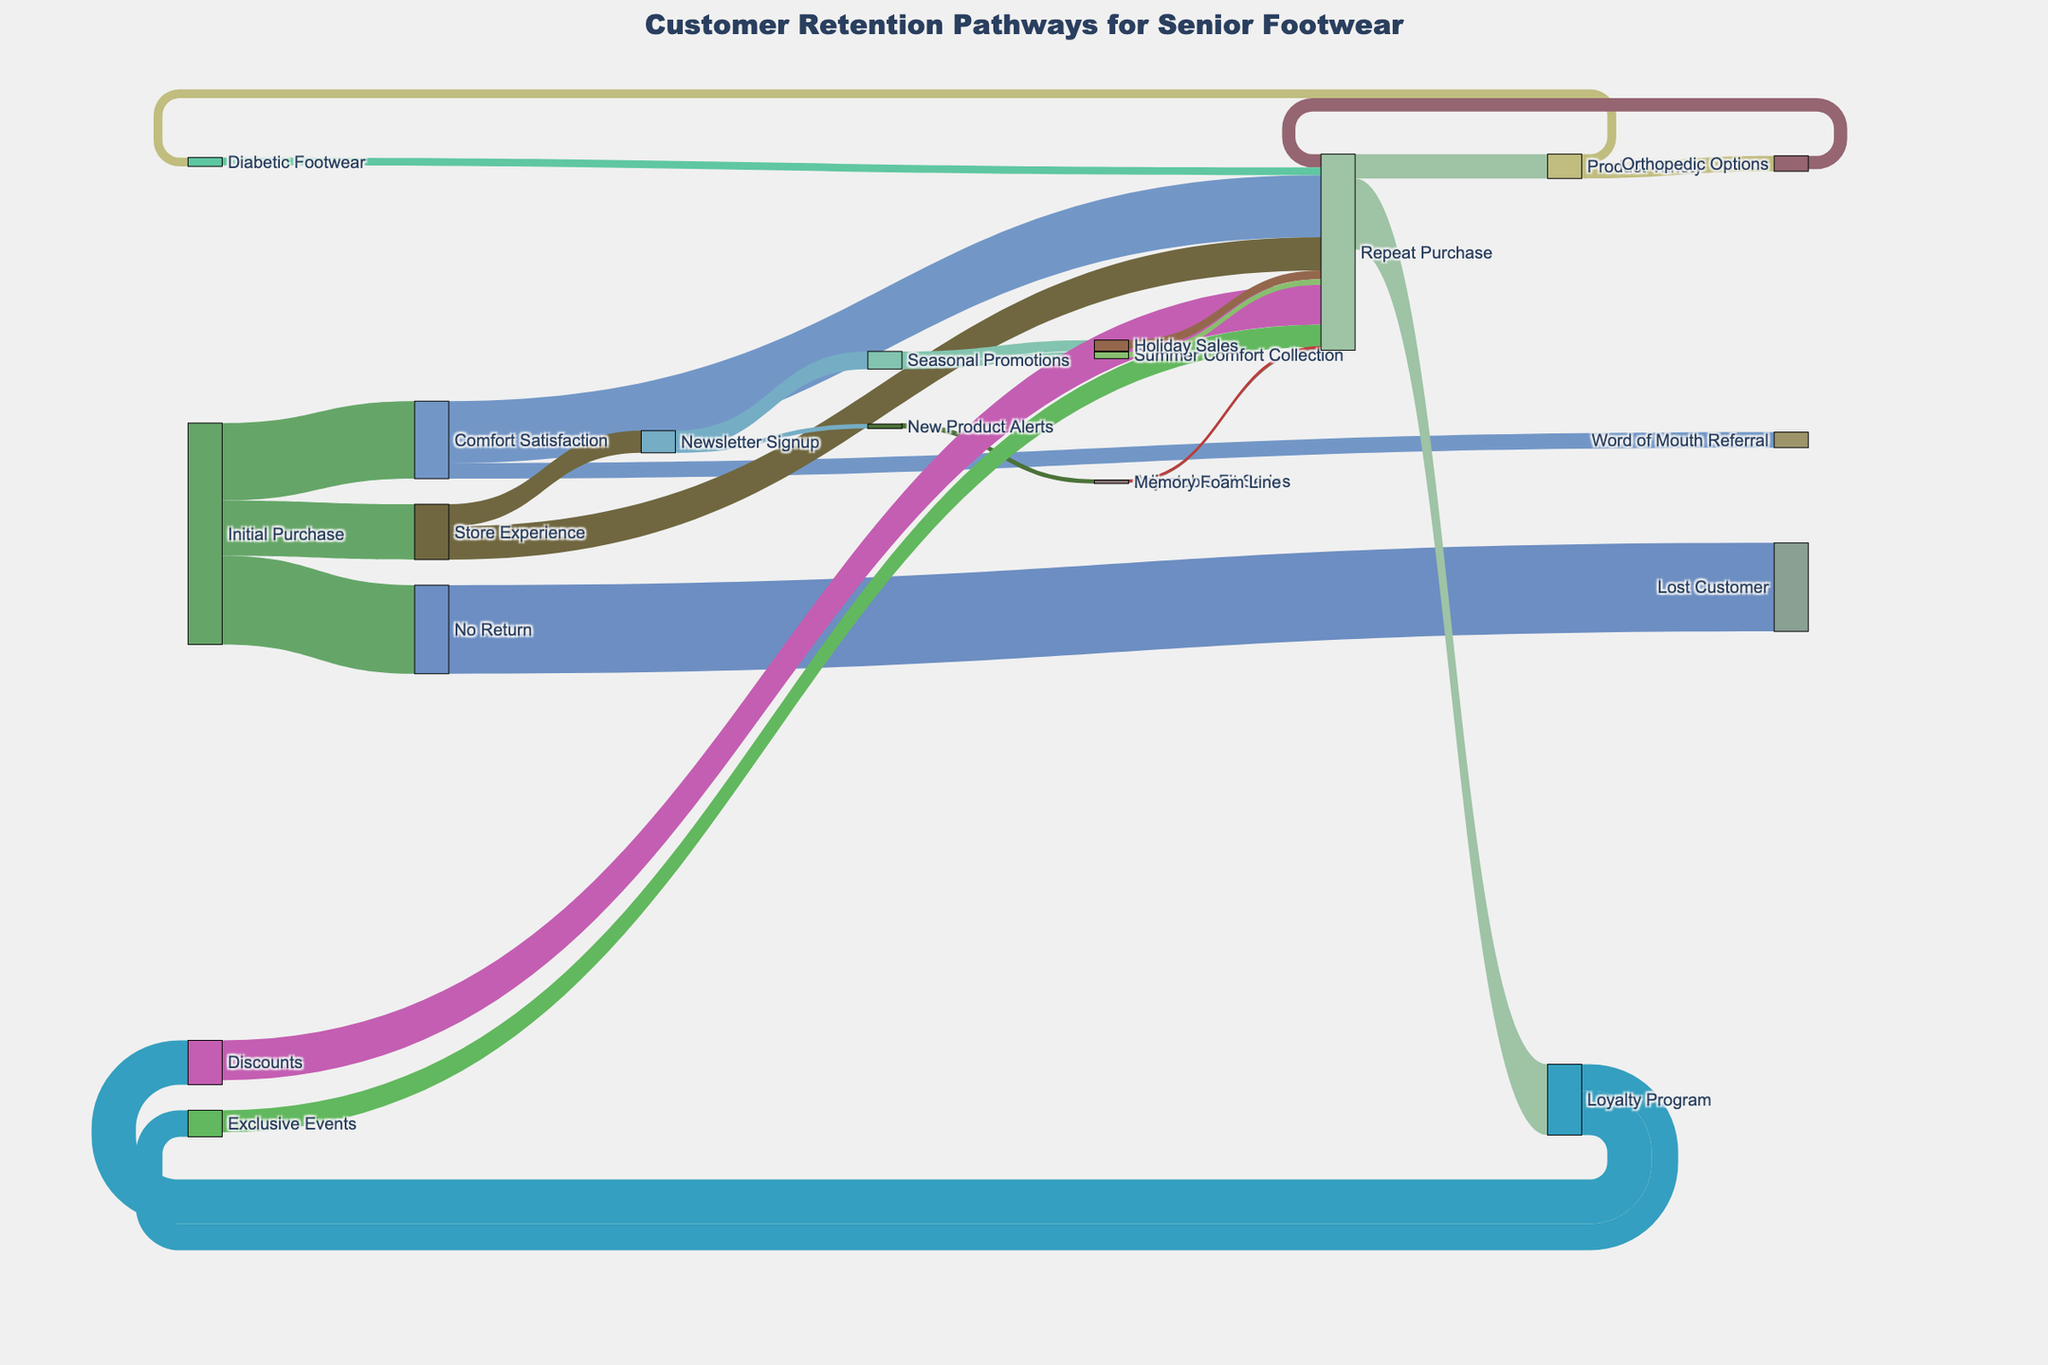What's the title of the figure? The title is displayed at the very top of the figure, centered for better readability.
Answer: "Customer Retention Pathways for Senior Footwear" How many customers did not return after their initial purchase? Identify the flow labeled "No Return" coming out of "Initial Purchase" and check the value associated with it.
Answer: 400 Between “Comfort Satisfaction” and “Store Experience,” which pathway leads to more repeat purchases? Compare the values of the flows labeled "Repeat Purchase" from both “Comfort Satisfaction” and “Store Experience.”
Answer: "Comfort Satisfaction" Which factor under "Loyalty Program" leads to more repeat purchases? Look at the values of the flows stemming from "Loyalty Program" and check which one has the higher value.
Answer: Discounts What is the total number of customers who signed up for the newsletter? Sum up the values of flows labeled "Newsletter Signup" stemming from "Store Experience."
Answer: 100 What's the sum of customers who made a repeat purchase through "Discounts" and "Exclusive Events"? Add the values of the flows labeled "Repeat Purchase" under "Discounts" and "Exclusive Events." 180 + 100 = 280
Answer: 280 How many customers lead to a referral via "Word of Mouth Referral"? Find the flow labeled "Word of Mouth Referral" coming out of "Comfort Satisfaction" and check its value.
Answer: 70 Is "Orthopedic Options" or "Diabetic Footwear" more influential in leading to repeat purchases? Compare the values of the flows labeled “Repeat Purchase” under both "Orthopedic Options" and "Diabetic Footwear."
Answer: Orthopedic Options What percentage of customers who signed up for the "Newsletter" respond to "Seasonal Promotions"? Calculate the percentage by dividing the value for "Seasonal Promotions" by the total newsletter sign-ups and then multiply by 100. 80 / 100 * 100 = 80%
Answer: 80% Which has a higher customer retention influence, "Product Variety" or "Comfort Satisfaction"? Add up the values stemming from "Repeat Purchase" under both "Product Variety" and "Comfort Satisfaction." For "Comfort Satisfaction": 280  and for "Product Variety": 110. Compare the totals.
Answer: Comfort Satisfaction 